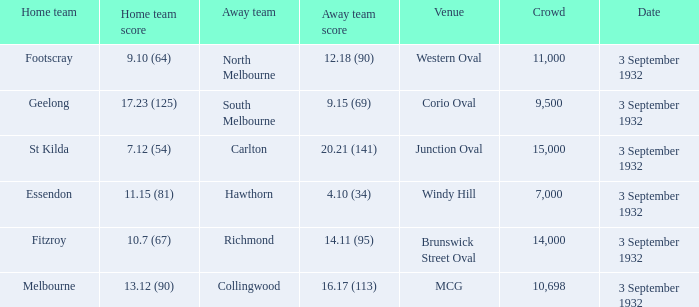What is the Home team score for the Away team of North Melbourne? 9.10 (64). 